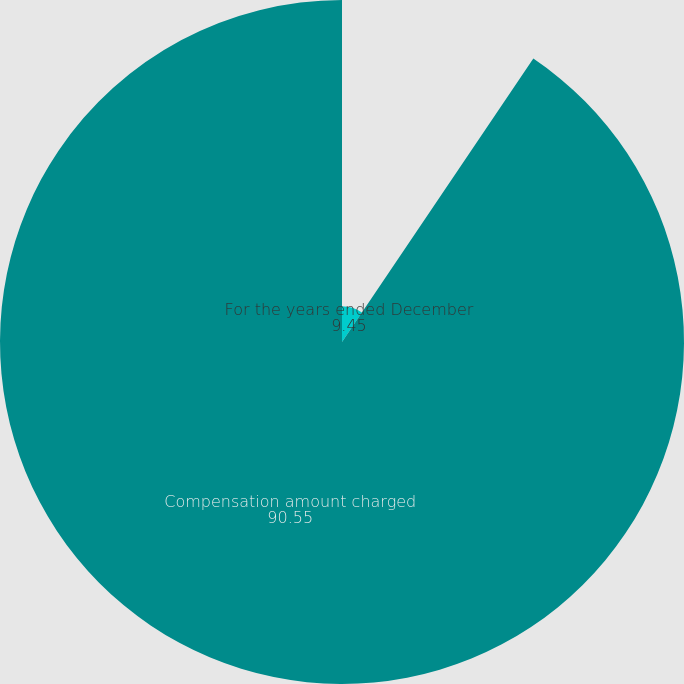<chart> <loc_0><loc_0><loc_500><loc_500><pie_chart><fcel>For the years ended December<fcel>Compensation amount charged<nl><fcel>9.45%<fcel>90.55%<nl></chart> 